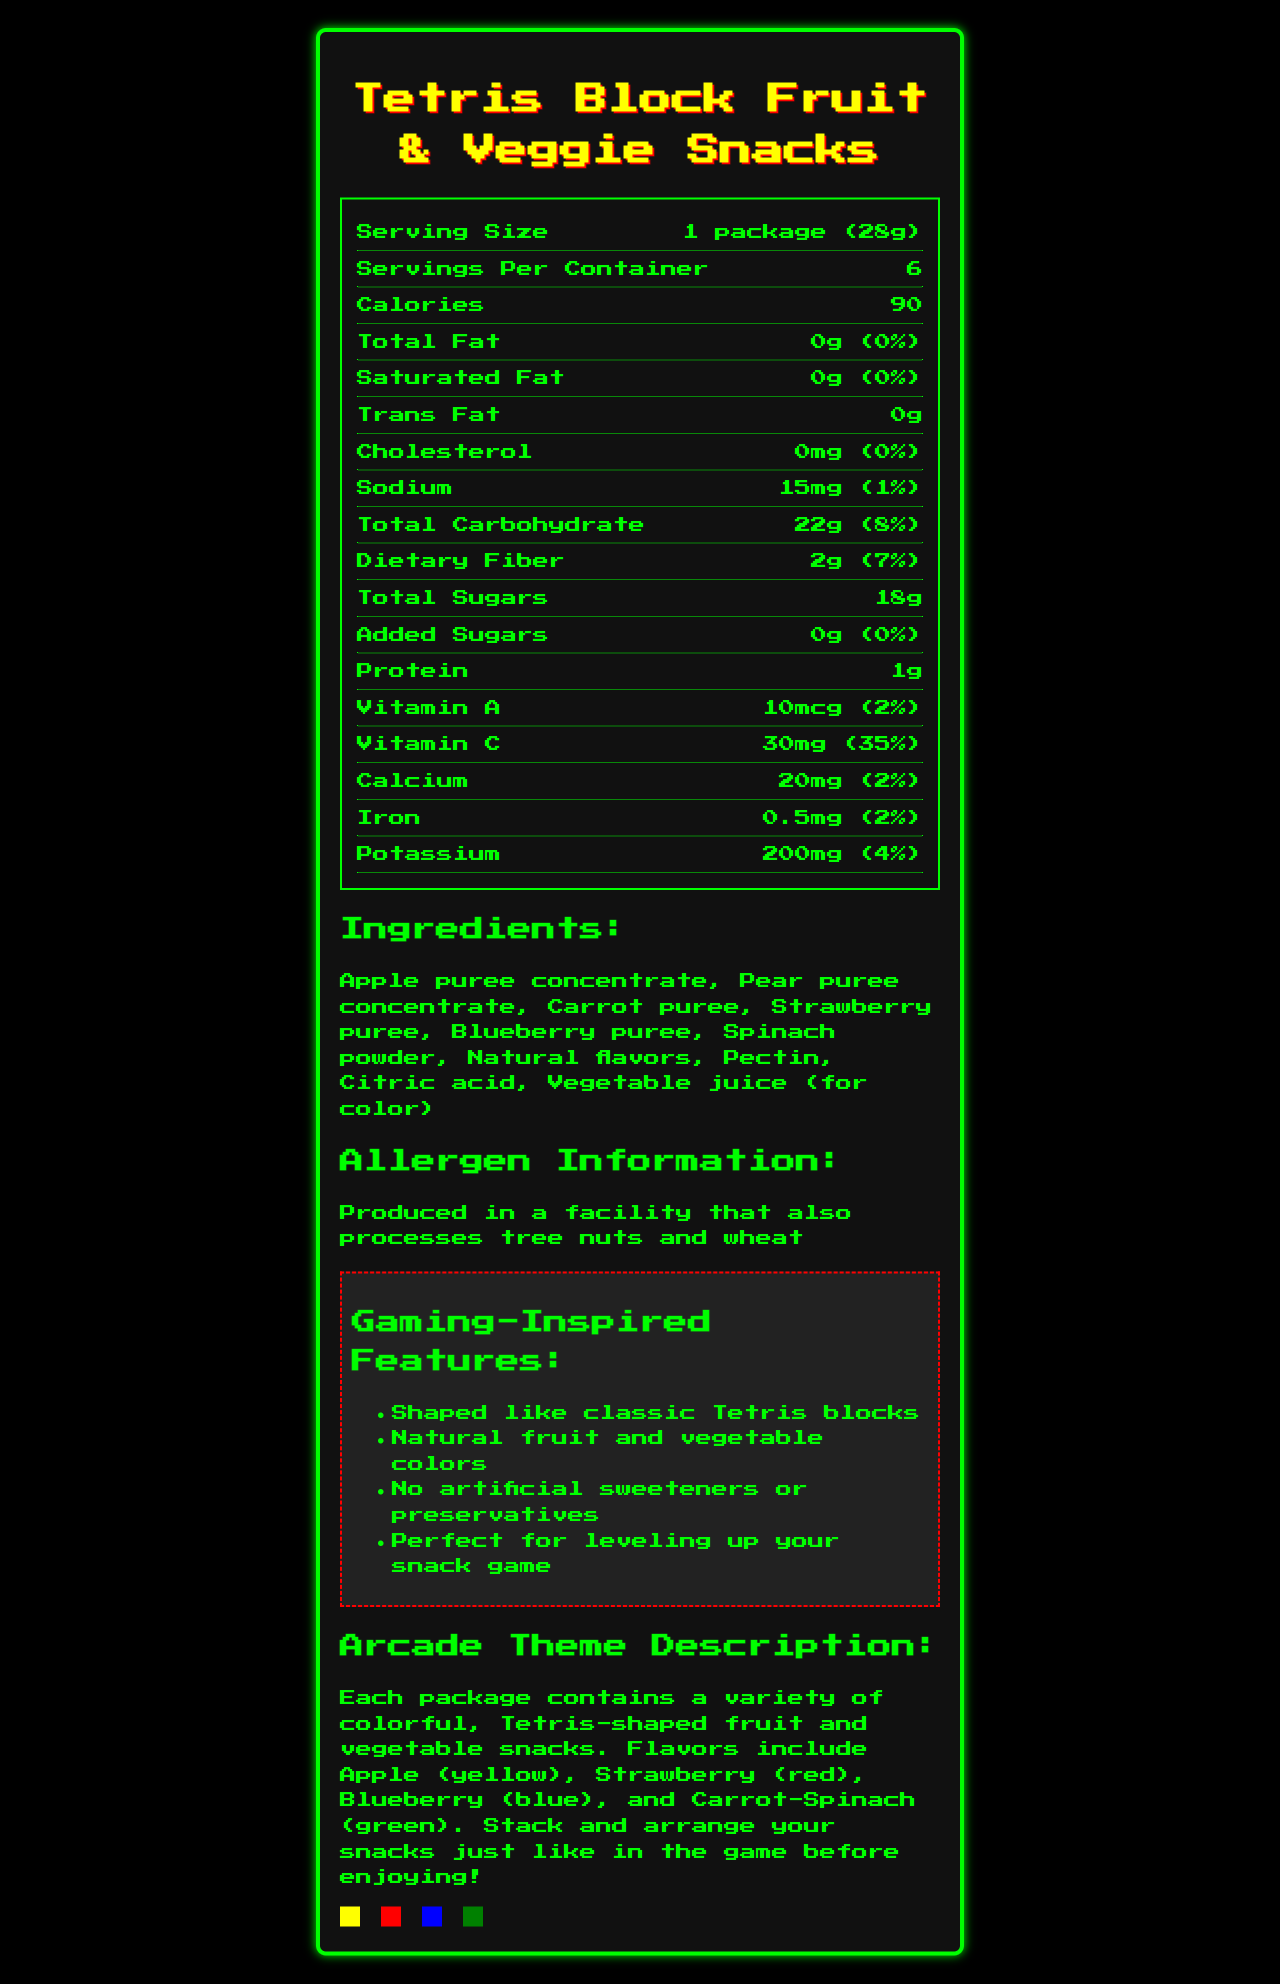what is the serving size? The serving size is mentioned directly in the nutrition facts section as "1 package (28g)".
Answer: 1 package (28g) how many calories are in one serving? The nutrition facts section lists the calories per serving as 90.
Answer: 90 what is the amount of dietary fiber per serving? The nutrition facts section states that the dietary fiber per serving is 2g.
Answer: 2g how much vitamin C is in one serving? The document specifies 30mg of vitamin C per serving.
Answer: 30mg what are the main ingredients of the Tetris Block Fruit & Veggie Snacks? The ingredients are listed under the Ingredients section.
Answer: Apple puree concentrate, Pear puree concentrate, Carrot puree, Strawberry puree, Blueberry puree, Spinach powder, Natural flavors, Pectin, Citric acid, Vegetable juice (for color) how much sodium is in a single serving? The amount of sodium per serving is listed as 15mg in the nutrition facts section.
Answer: 15mg are there any added sugars in this product? The nutrition facts section shows that added sugars amount is 0g per serving.
Answer: No what colors correspond to each flavor of the snacks? The Arcade Theme Description section provides this color mapping.
Answer: Apple (yellow), Strawberry (red), Blueberry (blue), Carrot-Spinach (green) which vitamin has the highest daily value percentage in one serving? A. Vitamin A B. Vitamin C C. Calcium D. Iron The document shows Vitamin C at 35%, which is the highest daily value percentage among the listed vitamins and minerals.
Answer: B what is the total amount of carbohydrates in one serving? A. 15g B. 18g C. 22g D. 25g The total carbohydrates per serving are 22g as listed in the nutrition facts section.
Answer: C does this product contain any allergens? The product is produced in a facility that also processes tree nuts and wheat, which is mentioned in the Allergen Information section.
Answer: Yes summarize the main idea of the document. The document provides comprehensive information about the Tetris Block Fruit & Veggie Snacks, emphasizing their nutritional content, ingredient composition, absence of artificial additives, and gaming-themed features.
Answer: The document is a nutrition facts label for Tetris Block Fruit & Veggie Snacks. It details nutritional information, ingredients, allergen info, and gaming-inspired claims. The snacks are shaped like Tetris blocks and come in various colors and flavors, inspired by classic arcade games. how does this product help in leveling up your snack game? The document mentions this as a claim in the Gaming-Inspired Features section, but it doesn’t provide specific details on how it achieves this.
Answer: Cannot be determined 